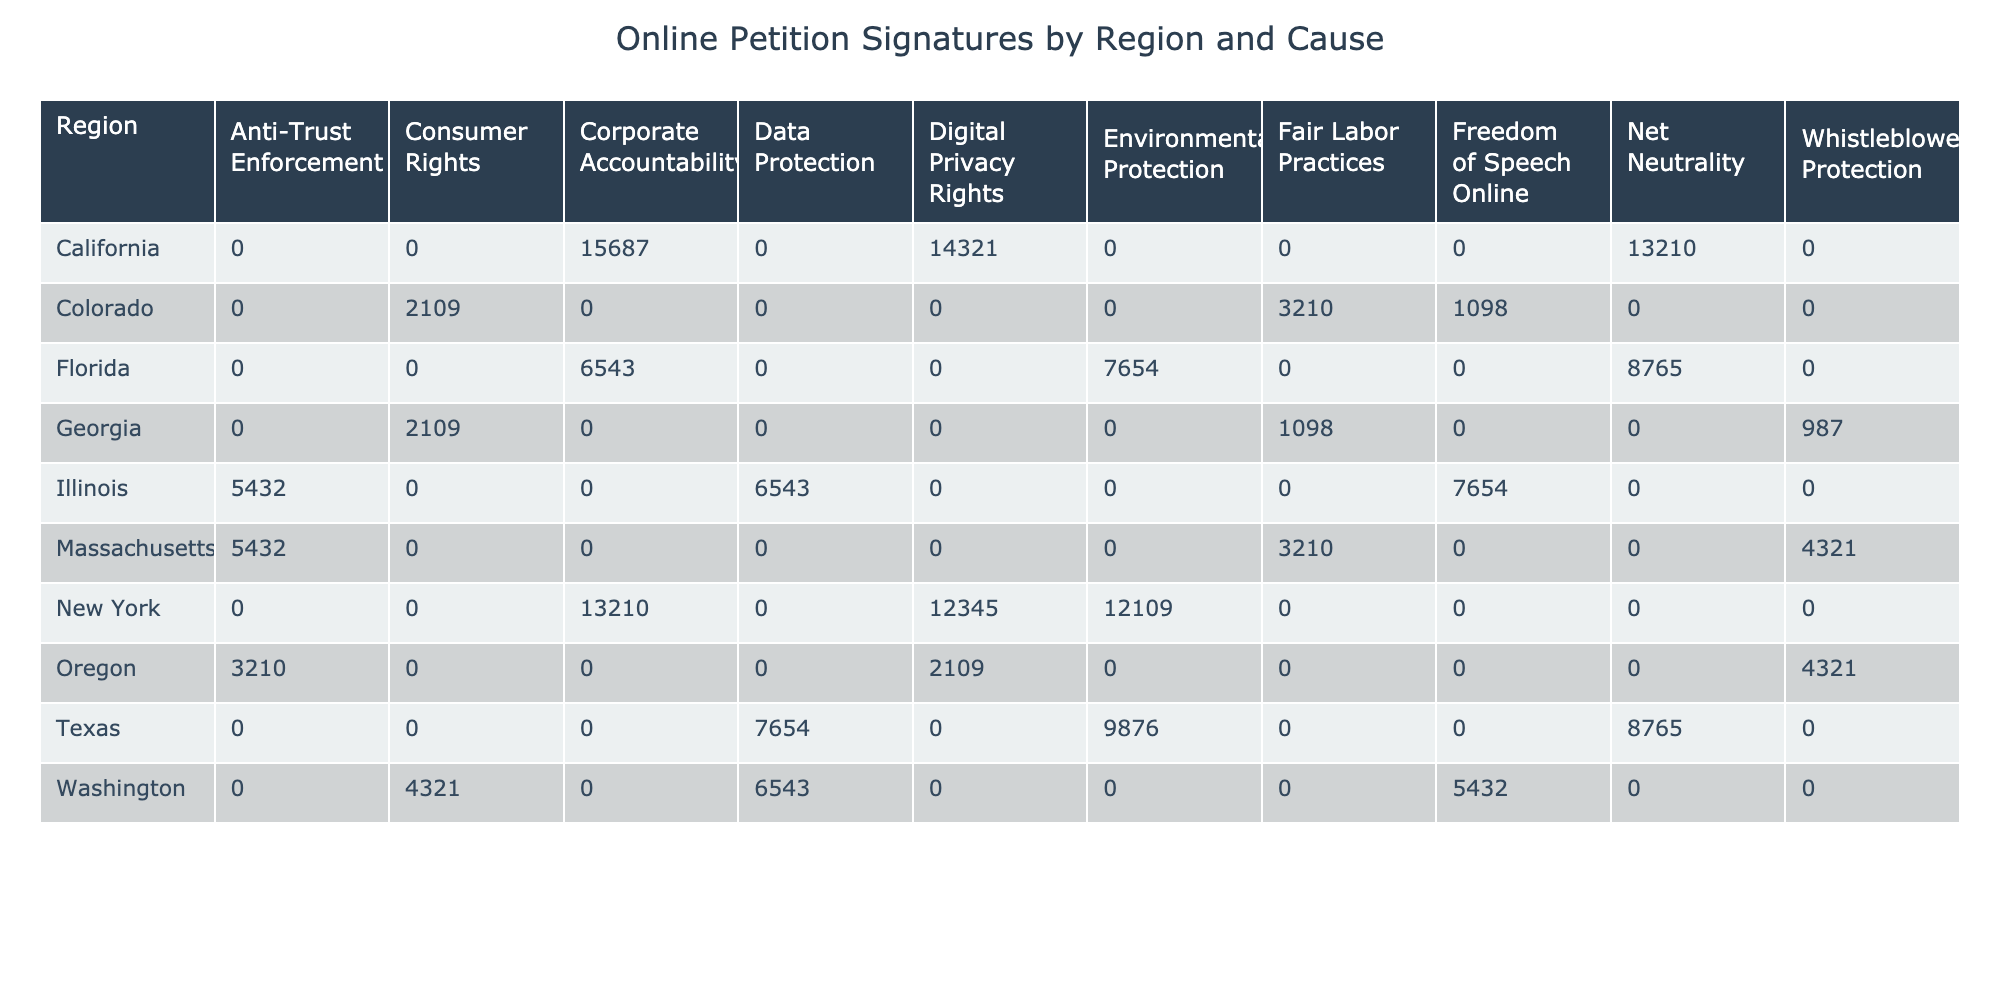What region has the highest number of signatures for Corporate Accountability? The table shows the signatures by cause and region. For Corporate Accountability, California has 15687 signatures, while New York has 13210 signatures. Therefore, California has the highest number of signatures for this cause.
Answer: California What is the total number of signatures for Digital Privacy Rights across all regions? To find the total for Digital Privacy Rights, we need to sum the values from the relevant regions: California (14321) + New York (12345) + Oregon (2109) = 28875.
Answer: 28875 Is there a region with zero signatures for any cause? By examining the table, there are no regions listed with zero signatures for any cause as all entries have at least some signatures recorded.
Answer: No Which cause has the least number of signatures in Georgia? In Georgia, the causes listed are Consumer Rights (2109) and Whistleblower Protection (987). The cause with the least signatures is Whistleblower Protection with only 987 signatures.
Answer: Whistleblower Protection What is the difference in signatures for Environmental Protection between New York and Florida? For Environmental Protection, New York has 12109 signatures and Florida has 7654 signatures. The difference is 12109 - 7654 = 4455 signatures.
Answer: 4455 Which cause has the most signatures in California and what is the value? In California, the causes and their signatures are: Corporate Accountability (15687), Digital Privacy Rights (14321), and Net Neutrality (13210). The cause with the most signatures is Corporate Accountability with 15687 signatures.
Answer: Corporate Accountability, 15687 What are the average signatures for Anti-Trust Enforcement across applicable regions? The regions with Anti-Trust Enforcement are Massachusetts (5432) and Oregon (3210). The average is calculated as (5432 + 3210) / 2 = 4321.
Answer: 4321 Which region has the most signatures for Environmental Protection? Looking at the Environmental Protection signatures, New York has 12109 signatures while Florida shows 7654. Therefore, New York has the most signatures for Environmental Protection.
Answer: New York How many regions show greater than 8000 signatures for the cause of Net Neutrality? The regions for Net Neutrality are Florida (8765) and California (13210). Both exceed 8000 signatures, resulting in a total of 2 regions with greater than 8000 signatures for this cause.
Answer: 2 